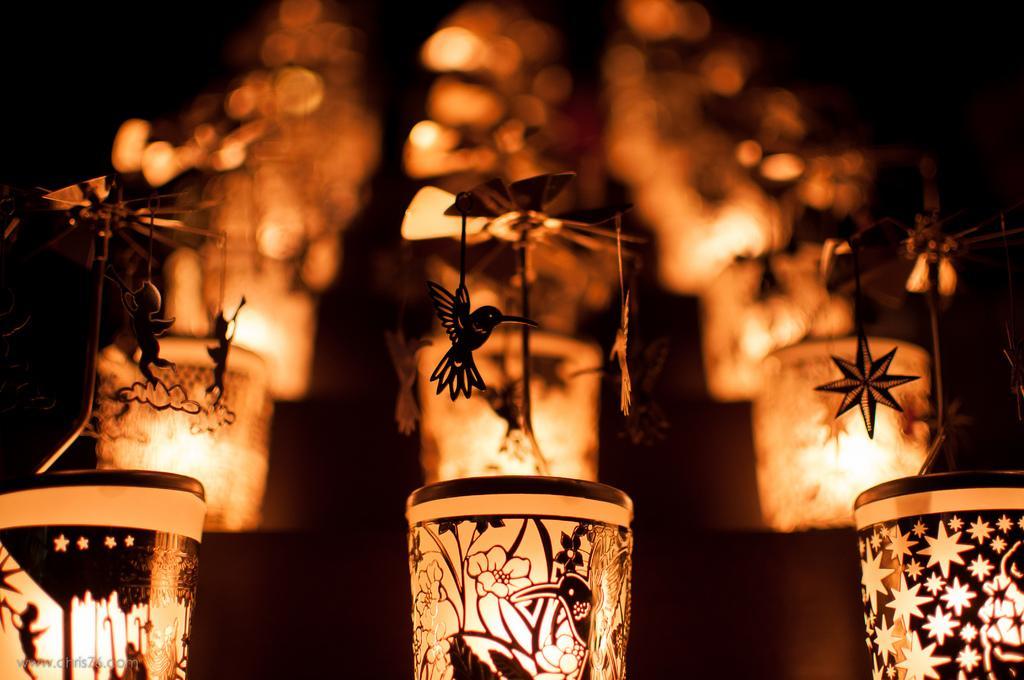How would you summarize this image in a sentence or two? In this image there are designed lantern lamps. In the background of the image it is blurry. 